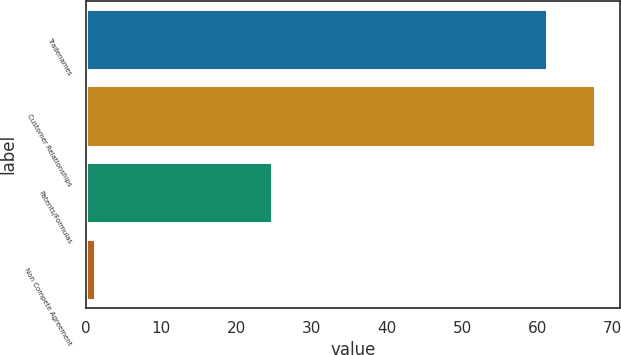<chart> <loc_0><loc_0><loc_500><loc_500><bar_chart><fcel>Tradenames<fcel>Customer Relationships<fcel>Patents/Formulas<fcel>Non Compete Agreement<nl><fcel>61.3<fcel>67.61<fcel>24.8<fcel>1.2<nl></chart> 